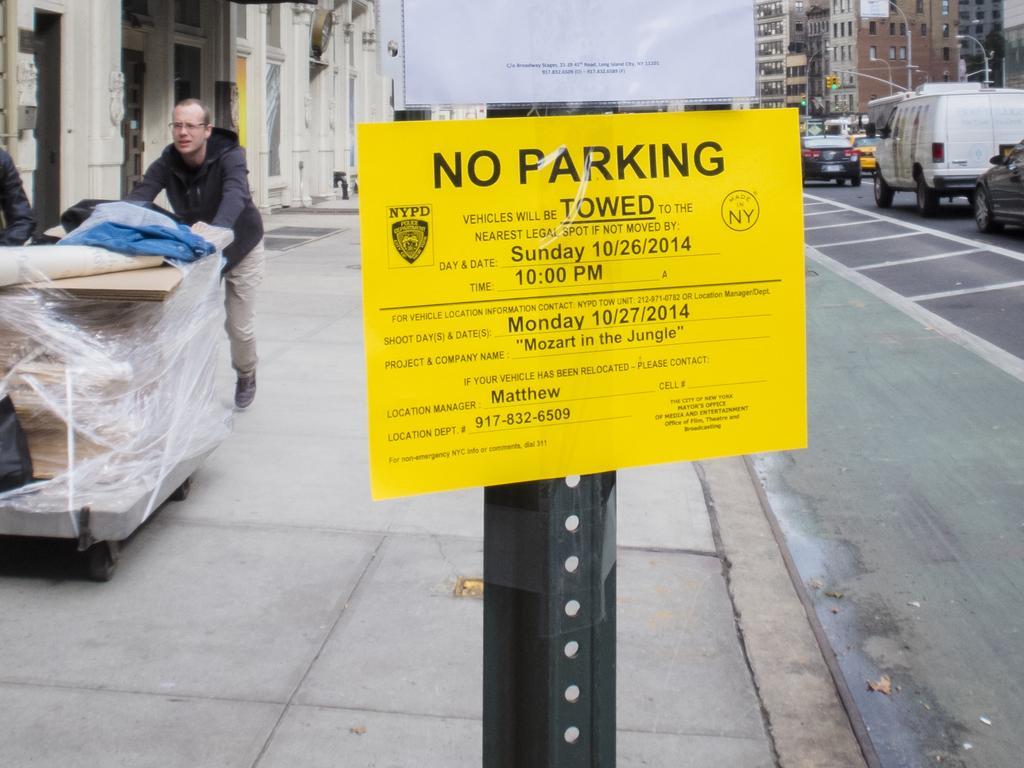In one or two sentences, can you explain what this image depicts? In this image, we can see a person. We can see the ground and an object on the left. There are a few buildings, poles, vehicles. We can see some boards with text. 